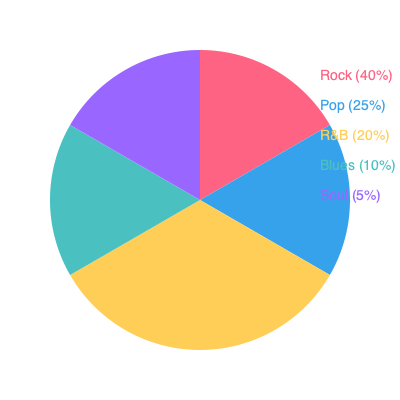Based on the pie chart showing the distribution of music genres in Jamie Archer's discography, what percentage of his music falls under the Rock genre? To answer this question, we need to analyze the pie chart provided:

1. The pie chart is divided into five sections, each representing a different music genre in Jamie Archer's discography.
2. Each section is labeled with the genre name and its corresponding percentage.
3. The sections are color-coded for easy identification.
4. Looking at the chart, we can see that the largest section is labeled "Rock (40%)".
5. This means that 40% of Jamie Archer's discography falls under the Rock genre.

Therefore, the percentage of Jamie Archer's music that falls under the Rock genre is 40%.
Answer: 40% 